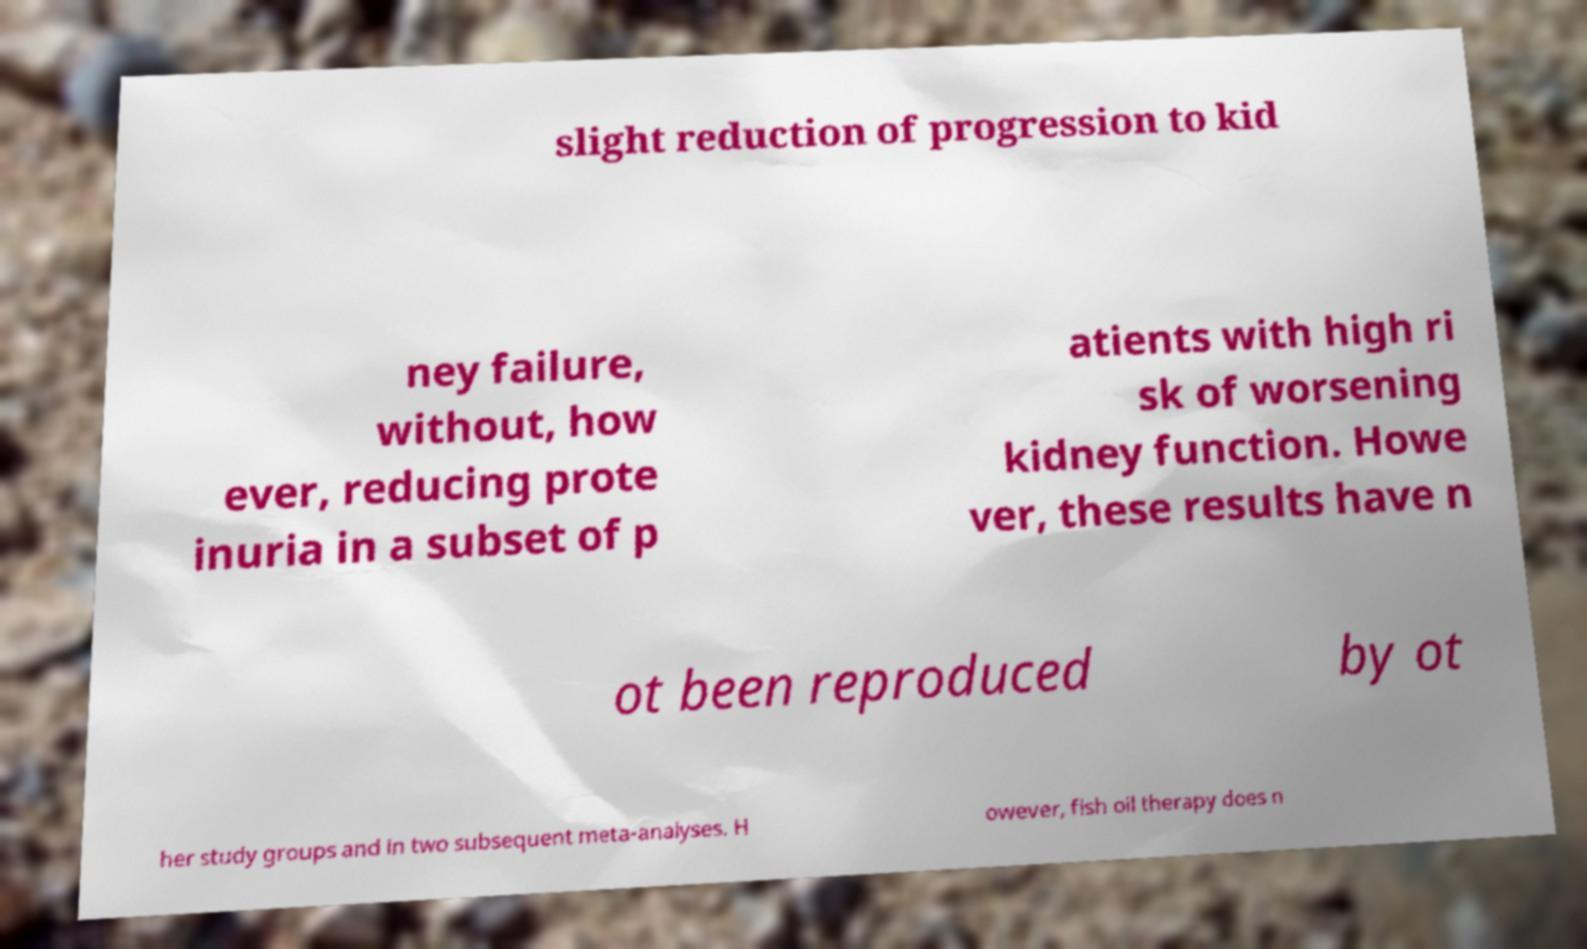Please read and relay the text visible in this image. What does it say? slight reduction of progression to kid ney failure, without, how ever, reducing prote inuria in a subset of p atients with high ri sk of worsening kidney function. Howe ver, these results have n ot been reproduced by ot her study groups and in two subsequent meta-analyses. H owever, fish oil therapy does n 